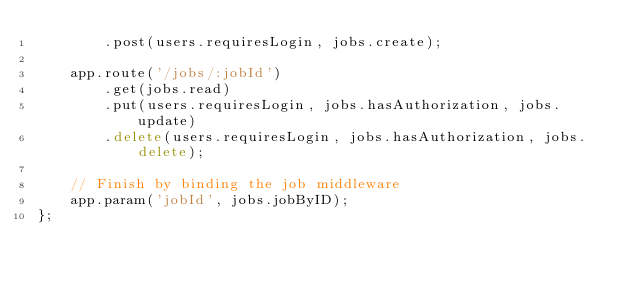Convert code to text. <code><loc_0><loc_0><loc_500><loc_500><_JavaScript_>		.post(users.requiresLogin, jobs.create);

	app.route('/jobs/:jobId')
		.get(jobs.read)
		.put(users.requiresLogin, jobs.hasAuthorization, jobs.update)
		.delete(users.requiresLogin, jobs.hasAuthorization, jobs.delete);

	// Finish by binding the job middleware
	app.param('jobId', jobs.jobByID);
};
</code> 